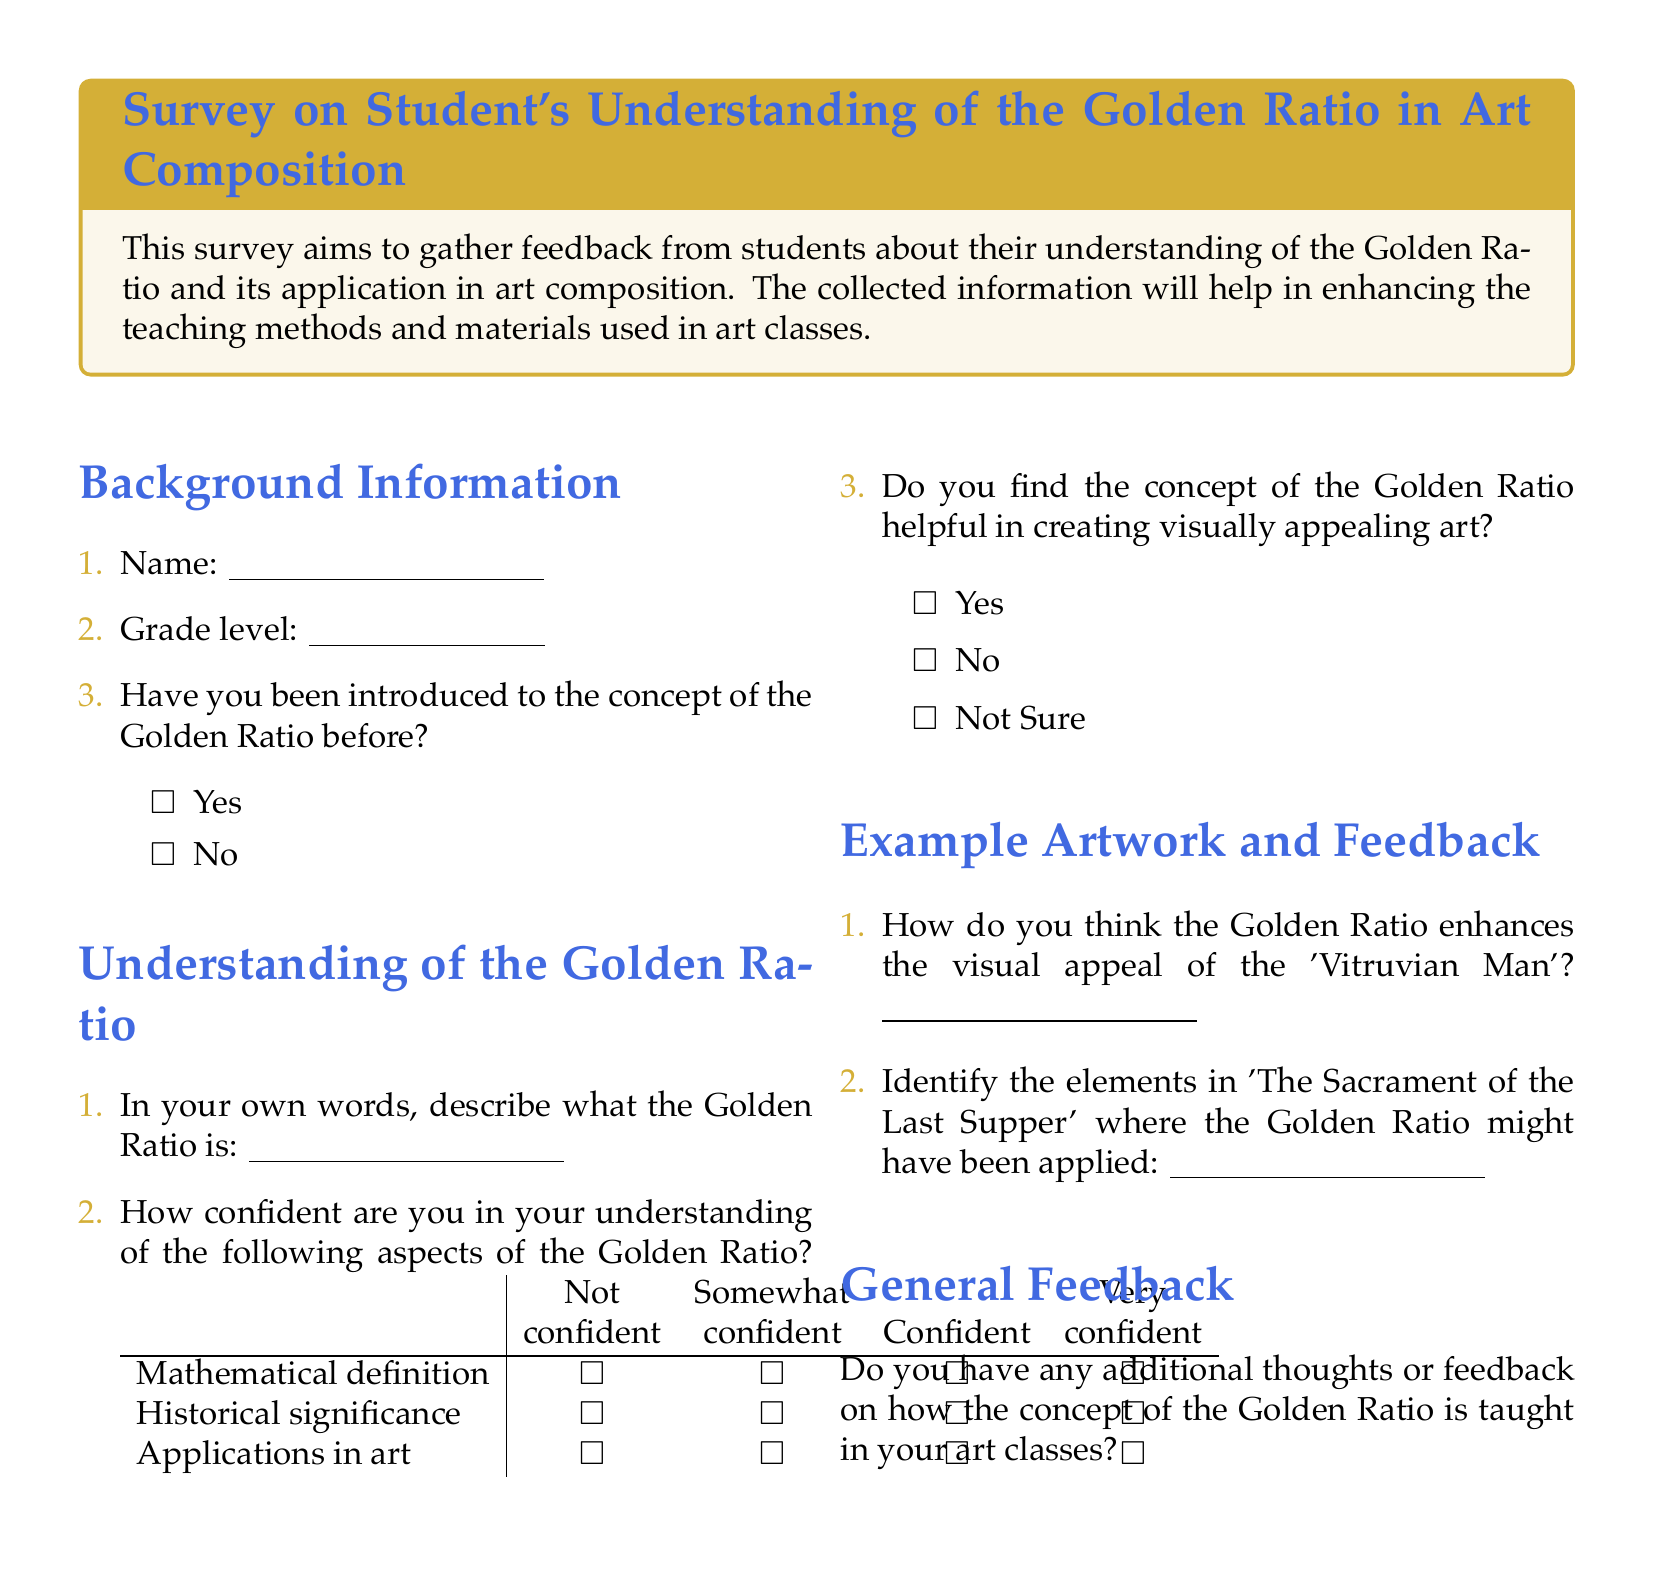What is the title of the survey? The title is specified in the tcolorbox at the top of the document.
Answer: Survey on Student's Understanding of the Golden Ratio in Art Composition How many aspects of the Golden Ratio are the students asked to rate their understanding of? The document lists three aspects for students to evaluate their understanding.
Answer: 3 Which artwork is mentioned as an example in the survey regarding the Golden Ratio? The document mentions 'The Sacrament of the Last Supper' as an example where the Golden Ratio might have been applied.
Answer: The Sacrament of the Last Supper What is the first question regarding background information? The document lists the first question in the background information section asking for the student's name.
Answer: Name How is the confidence level measured in the survey? The confidence level is measured through a table with four options labeled from "Not confident" to "Very confident".
Answer: Not, Somewhat, Confident, Very confident Do students find the Golden Ratio helpful in creating visually appealing art? The document includes a question asking students if they find the Golden Ratio helpful, with options for Yes, No, or Not Sure.
Answer: Yes, No, Not Sure How is general feedback solicited from students? The document includes a dedicated space for students to provide additional thoughts or feedback about the teaching of the Golden Ratio.
Answer: Additional thoughts or feedback What color is used for the title text in the tcolorbox? The title text color is defined in the document using an RGB value.
Answer: artblue 